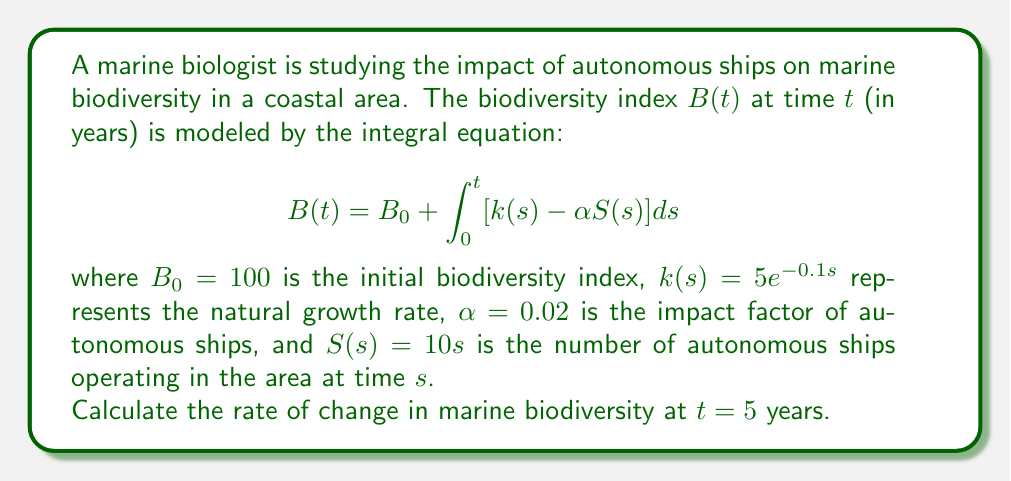Teach me how to tackle this problem. To solve this problem, we need to follow these steps:

1) The rate of change in marine biodiversity is given by the derivative of $B(t)$ with respect to $t$. We can use the Fundamental Theorem of Calculus to differentiate the integral equation.

2) Differentiating both sides of the equation with respect to $t$:

   $$\frac{dB}{dt} = \frac{d}{dt}\left(B_0 + \int_0^t [k(s) - \alpha S(s)] ds\right)$$

3) Using the Fundamental Theorem of Calculus:

   $$\frac{dB}{dt} = k(t) - \alpha S(t)$$

4) Now we need to substitute the given functions and the value of $t = 5$:

   $k(t) = 5e^{-0.1t}$
   $S(t) = 10t$
   $\alpha = 0.02$

5) Calculating $k(5)$:
   
   $k(5) = 5e^{-0.1(5)} = 5e^{-0.5} \approx 3.0327$

6) Calculating $S(5)$:
   
   $S(5) = 10(5) = 50$

7) Substituting these values into the equation:

   $$\frac{dB}{dt}\bigg|_{t=5} = 3.0327 - 0.02(50) = 3.0327 - 1 = 2.0327$$

Therefore, the rate of change in marine biodiversity at $t = 5$ years is approximately 2.0327 units per year.
Answer: $2.0327$ units/year 